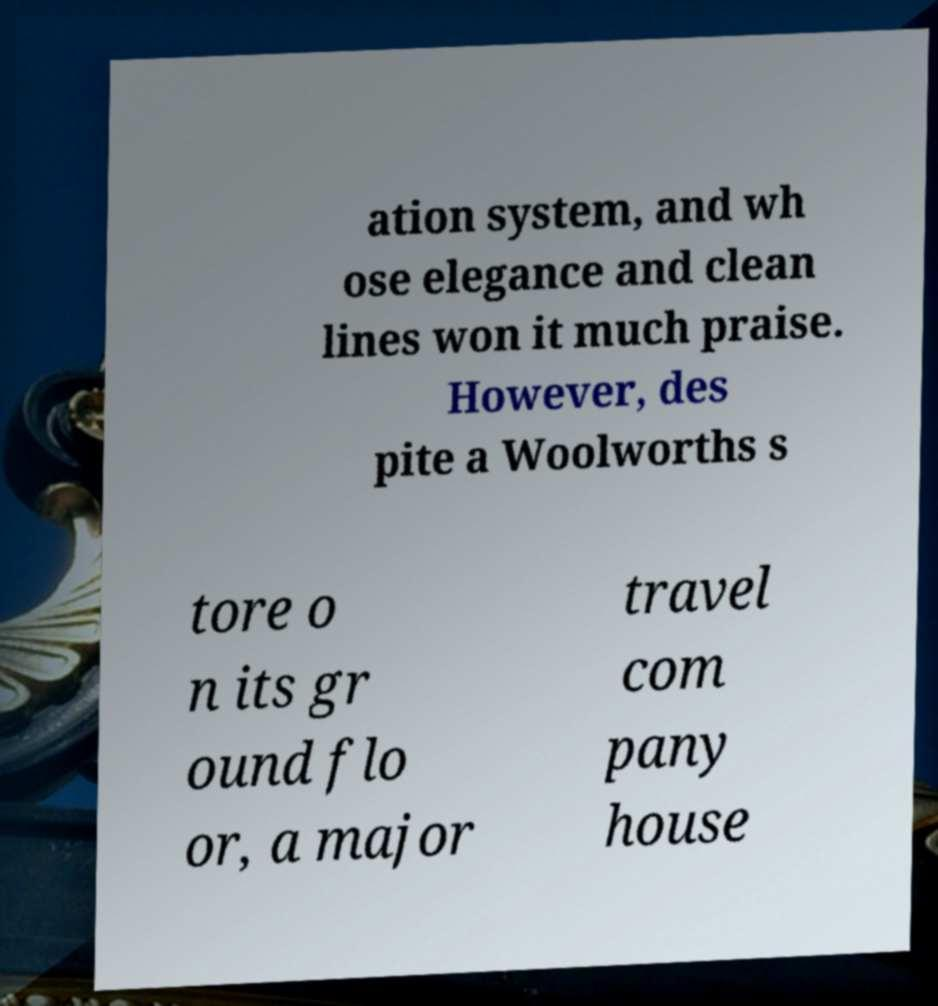Could you extract and type out the text from this image? ation system, and wh ose elegance and clean lines won it much praise. However, des pite a Woolworths s tore o n its gr ound flo or, a major travel com pany house 